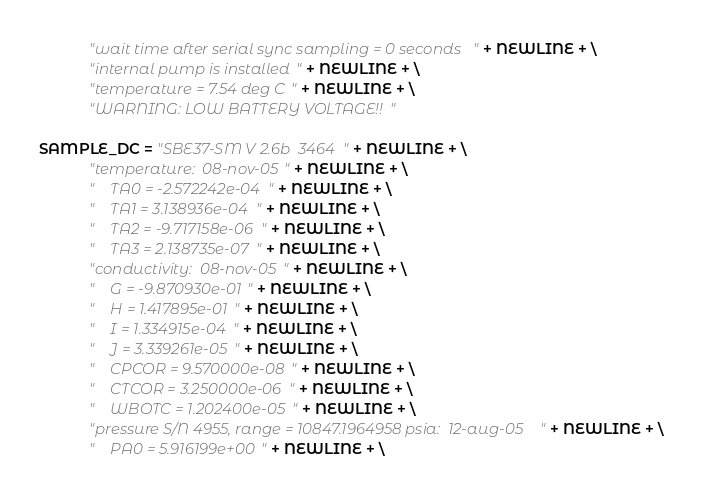Convert code to text. <code><loc_0><loc_0><loc_500><loc_500><_Python_>            "wait time after serial sync sampling = 0 seconds" + NEWLINE + \
            "internal pump is installed" + NEWLINE + \
            "temperature = 7.54 deg C" + NEWLINE + \
            "WARNING: LOW BATTERY VOLTAGE!!" 

SAMPLE_DC = "SBE37-SM V 2.6b  3464" + NEWLINE + \
            "temperature:  08-nov-05" + NEWLINE + \
            "    TA0 = -2.572242e-04" + NEWLINE + \
            "    TA1 = 3.138936e-04" + NEWLINE + \
            "    TA2 = -9.717158e-06" + NEWLINE + \
            "    TA3 = 2.138735e-07" + NEWLINE + \
            "conductivity:  08-nov-05" + NEWLINE + \
            "    G = -9.870930e-01" + NEWLINE + \
            "    H = 1.417895e-01" + NEWLINE + \
            "    I = 1.334915e-04" + NEWLINE + \
            "    J = 3.339261e-05" + NEWLINE + \
            "    CPCOR = 9.570000e-08" + NEWLINE + \
            "    CTCOR = 3.250000e-06" + NEWLINE + \
            "    WBOTC = 1.202400e-05" + NEWLINE + \
            "pressure S/N 4955, range = 10847.1964958 psia:  12-aug-05" + NEWLINE + \
            "    PA0 = 5.916199e+00" + NEWLINE + \</code> 